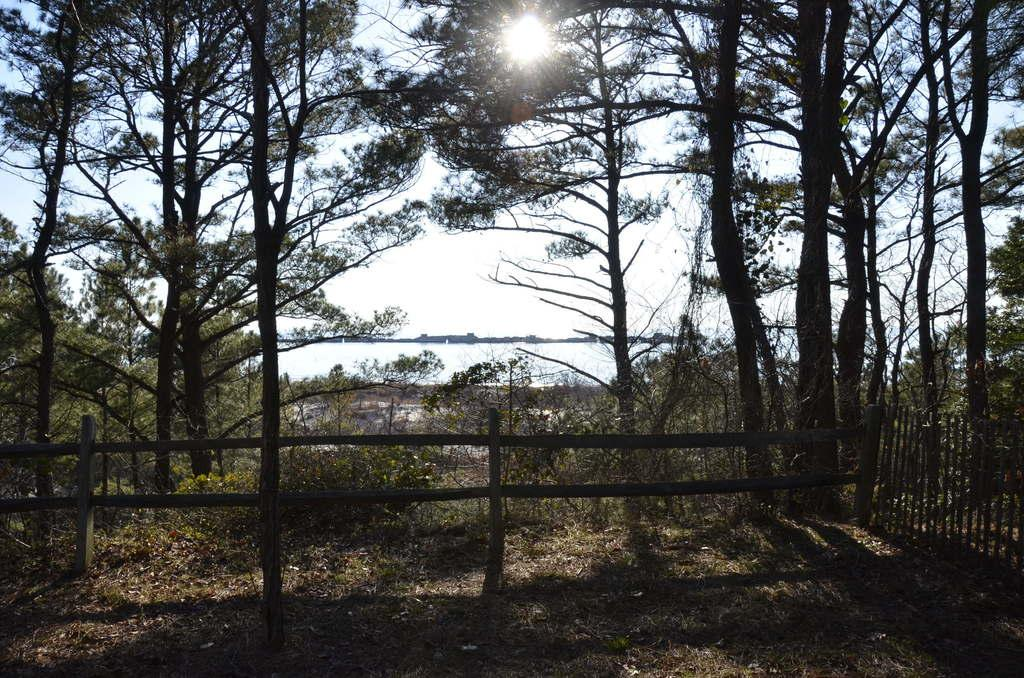What type of surface can be seen in the image? There is ground visible in the image. What is on the ground in the image? There are leaves on the ground. What type of structure is present in the image? There is a wooden railing in the image. What type of vegetation is visible in the image? There are trees in the image. What is visible in the background of the image? The sky and the sun are visible in the background of the image. What type of stamp can be seen on the knee in the image? There is no stamp or knee present in the image. 